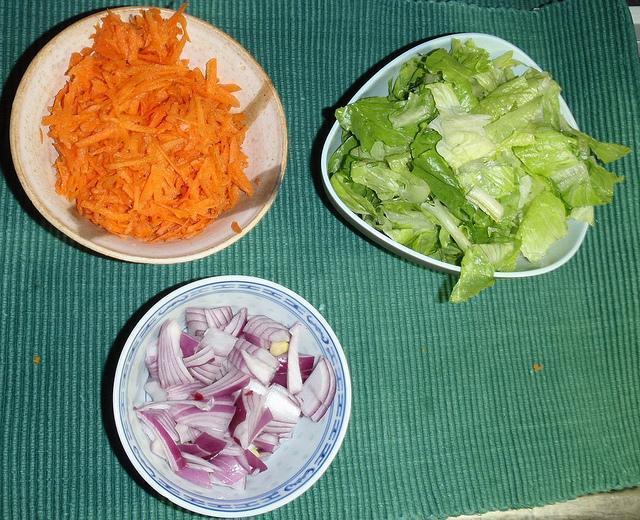What type of food are all of these?
Choose the right answer from the provided options to respond to the question.
Options: Vegetables, protein, fruit, starch. Vegetables. 